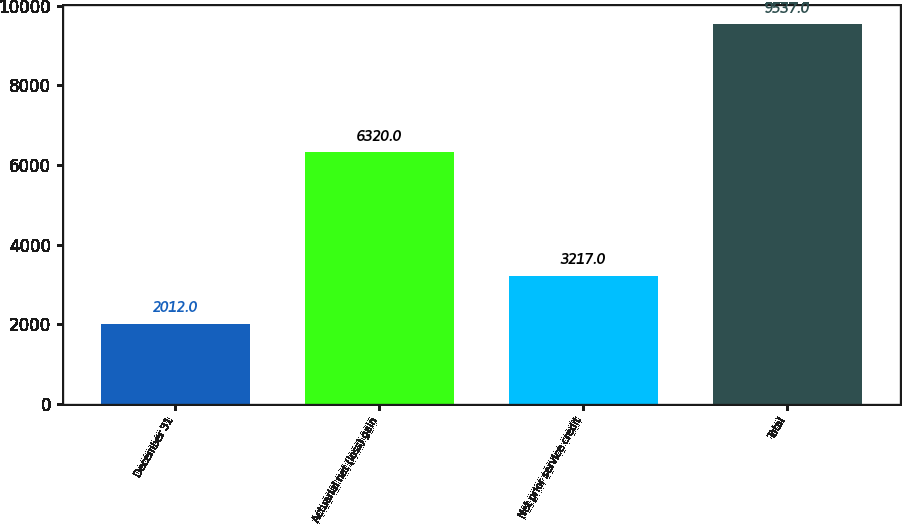Convert chart. <chart><loc_0><loc_0><loc_500><loc_500><bar_chart><fcel>December 31<fcel>Actuarial net (loss) gain<fcel>Net prior service credit<fcel>Total<nl><fcel>2012<fcel>6320<fcel>3217<fcel>9537<nl></chart> 